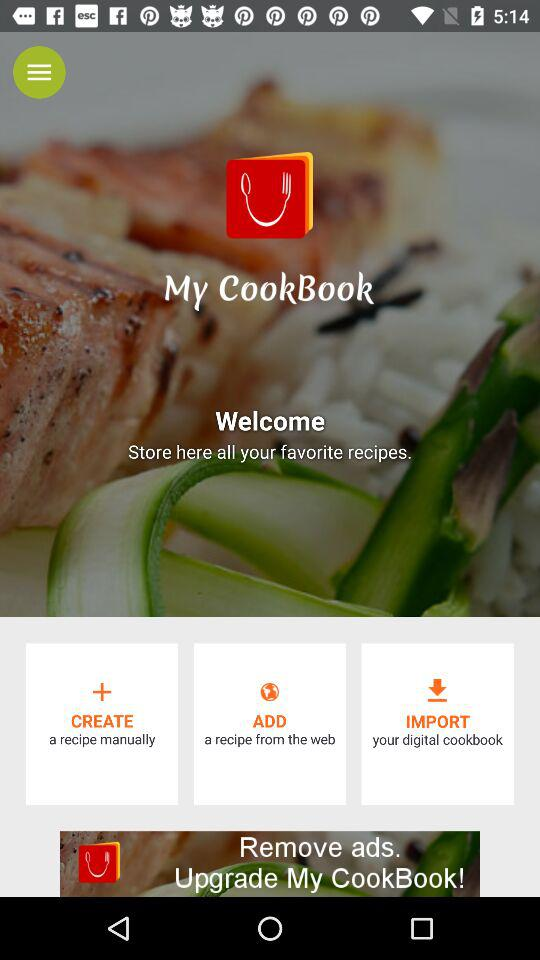What is the application name? The application name is "My CookBook". 